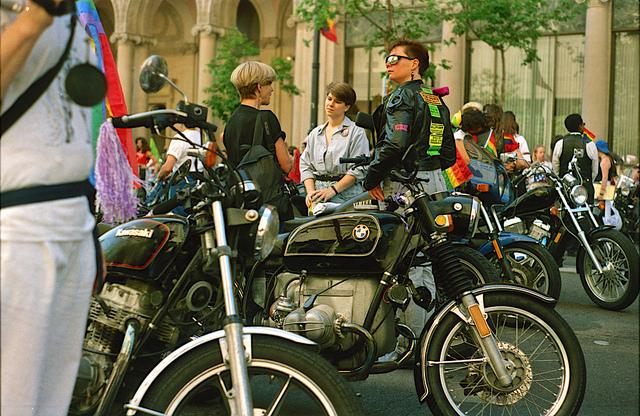What model is the closest motorcycle?
Write a very short answer. Kawasaki. Are there rainbow flags in this picture?
Concise answer only. Yes. What are the bikers doing?
Short answer required. Standing. Are the bikes in motion?
Concise answer only. No. 